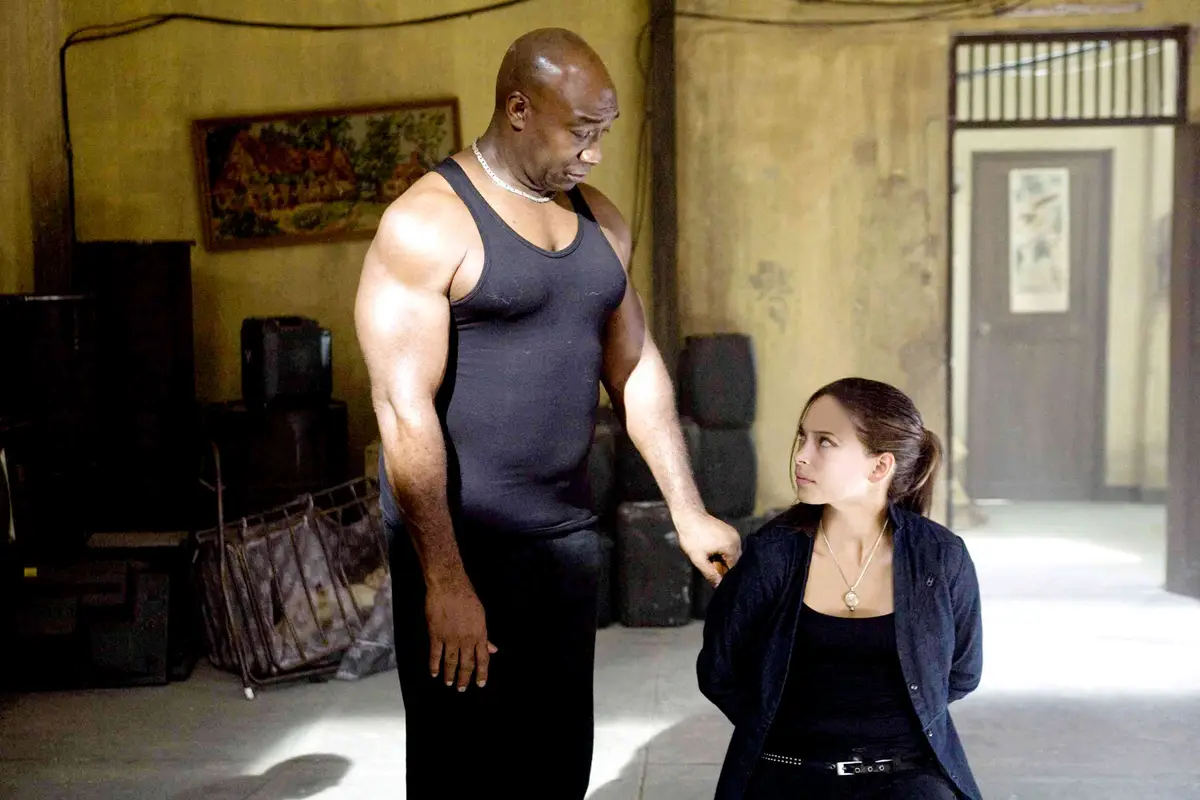Describe the emotional atmosphere conveyed by the characters' expressions and body language. The atmosphere seems emotionally intense yet caring. The man's posture, while imposing, is softened by his direct yet tender gaze towards the young woman. His large physique contrasts with the protective or reassuring gesture he makes towards her. She, in return, appears contemplative and slightly cautious, possibly indicating trust or the seeking of guidance. The interaction seems deeply significant, reflecting themes of guidance, reassurance, or mutual respect. 